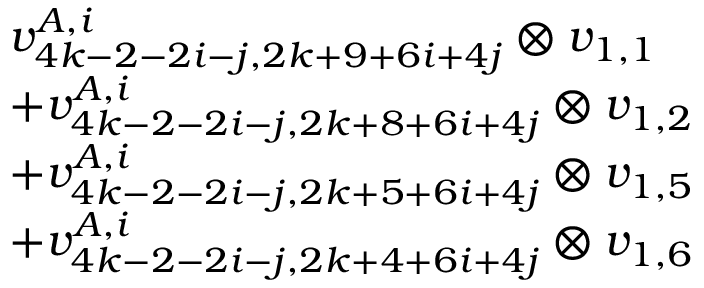<formula> <loc_0><loc_0><loc_500><loc_500>\begin{array} { r l } & { v _ { 4 k - 2 - 2 i - j , 2 k + 9 + 6 i + 4 j } ^ { A , i } \otimes v _ { 1 , 1 } } \\ & { + v _ { 4 k - 2 - 2 i - j , 2 k + 8 + 6 i + 4 j } ^ { A , i } \otimes v _ { 1 , 2 } } \\ & { + v _ { 4 k - 2 - 2 i - j , 2 k + 5 + 6 i + 4 j } ^ { A , i } \otimes v _ { 1 , 5 } } \\ & { + v _ { 4 k - 2 - 2 i - j , 2 k + 4 + 6 i + 4 j } ^ { A , i } \otimes v _ { 1 , 6 } } \end{array}</formula> 